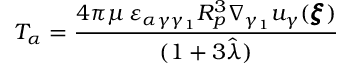Convert formula to latex. <formula><loc_0><loc_0><loc_500><loc_500>T _ { \alpha } = \frac { 4 \pi \mu \, \varepsilon _ { \alpha \gamma \gamma _ { 1 } } R _ { p } ^ { 3 } \nabla _ { \gamma _ { 1 } } u _ { \gamma } ( { \pm b \xi } ) } { ( 1 + 3 \hat { \lambda } ) }</formula> 